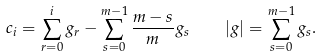Convert formula to latex. <formula><loc_0><loc_0><loc_500><loc_500>c _ { i } = \sum _ { r = 0 } ^ { i } g _ { r } - \sum _ { s = 0 } ^ { m - 1 } \frac { m - s } { m } g _ { s } \quad | g | = \sum _ { s = 0 } ^ { m - 1 } g _ { s } .</formula> 